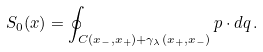<formula> <loc_0><loc_0><loc_500><loc_500>S _ { 0 } ( x ) = \oint _ { C ( x _ { - } , x _ { + } ) + \gamma _ { \lambda } ( x _ { + } , x _ { - } ) } p \cdot d q \, .</formula> 